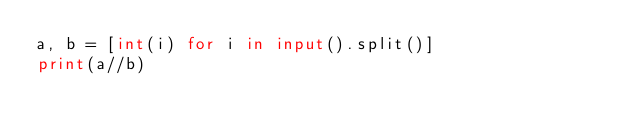<code> <loc_0><loc_0><loc_500><loc_500><_Python_>a, b = [int(i) for i in input().split()]
print(a//b)
</code> 